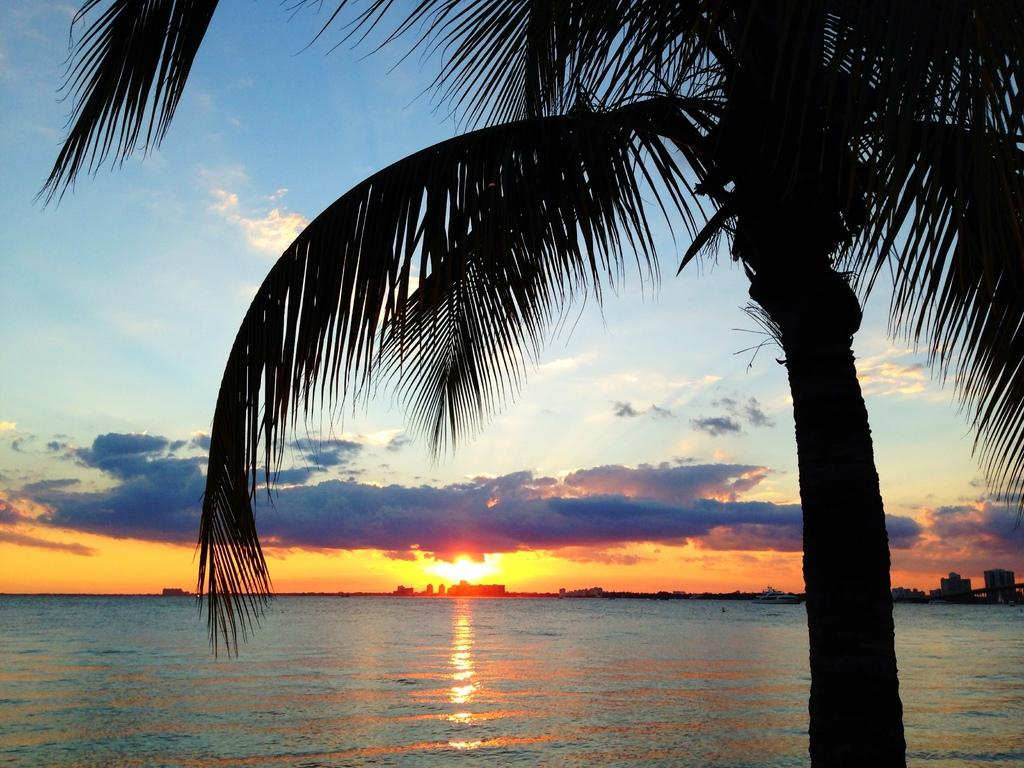What type of plant can be seen in the image? There is a tree with leaves in the image. What can be seen in the background of the image? Water and the sky are visible in the background of the image. What is the weather like in the image? The sun is shining in the distance, and clouds are present in the sky, suggesting a partly cloudy day. Can you describe the sky in the image? The sky is visible in the background of the image, with clouds present. What color of paint is being used on the arm in the image? There is no arm or paint present in the image; it features a tree, water, and a sky with clouds. 